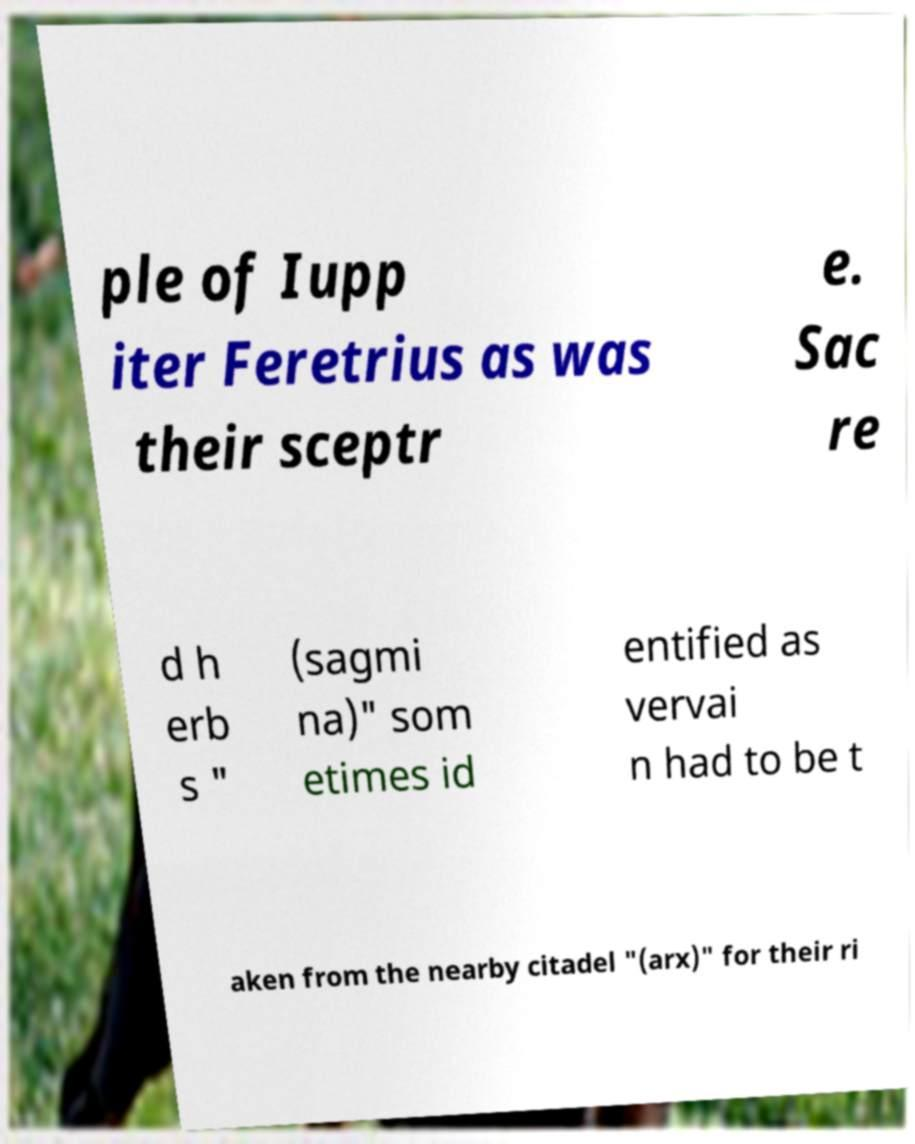Can you accurately transcribe the text from the provided image for me? ple of Iupp iter Feretrius as was their sceptr e. Sac re d h erb s " (sagmi na)" som etimes id entified as vervai n had to be t aken from the nearby citadel "(arx)" for their ri 